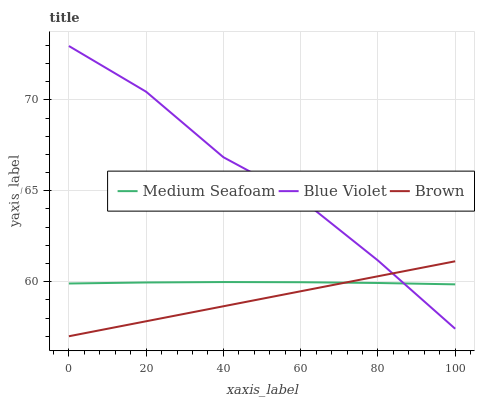Does Brown have the minimum area under the curve?
Answer yes or no. Yes. Does Blue Violet have the maximum area under the curve?
Answer yes or no. Yes. Does Medium Seafoam have the minimum area under the curve?
Answer yes or no. No. Does Medium Seafoam have the maximum area under the curve?
Answer yes or no. No. Is Brown the smoothest?
Answer yes or no. Yes. Is Blue Violet the roughest?
Answer yes or no. Yes. Is Medium Seafoam the smoothest?
Answer yes or no. No. Is Medium Seafoam the roughest?
Answer yes or no. No. Does Brown have the lowest value?
Answer yes or no. Yes. Does Blue Violet have the lowest value?
Answer yes or no. No. Does Blue Violet have the highest value?
Answer yes or no. Yes. Does Medium Seafoam have the highest value?
Answer yes or no. No. Does Brown intersect Medium Seafoam?
Answer yes or no. Yes. Is Brown less than Medium Seafoam?
Answer yes or no. No. Is Brown greater than Medium Seafoam?
Answer yes or no. No. 